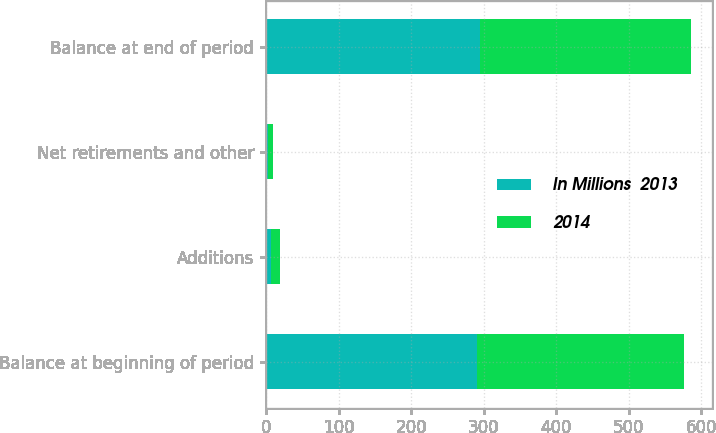Convert chart. <chart><loc_0><loc_0><loc_500><loc_500><stacked_bar_chart><ecel><fcel>Balance at beginning of period<fcel>Additions<fcel>Net retirements and other<fcel>Balance at end of period<nl><fcel>In Millions  2013<fcel>291<fcel>7<fcel>3<fcel>295<nl><fcel>2014<fcel>285<fcel>12<fcel>6<fcel>291<nl></chart> 